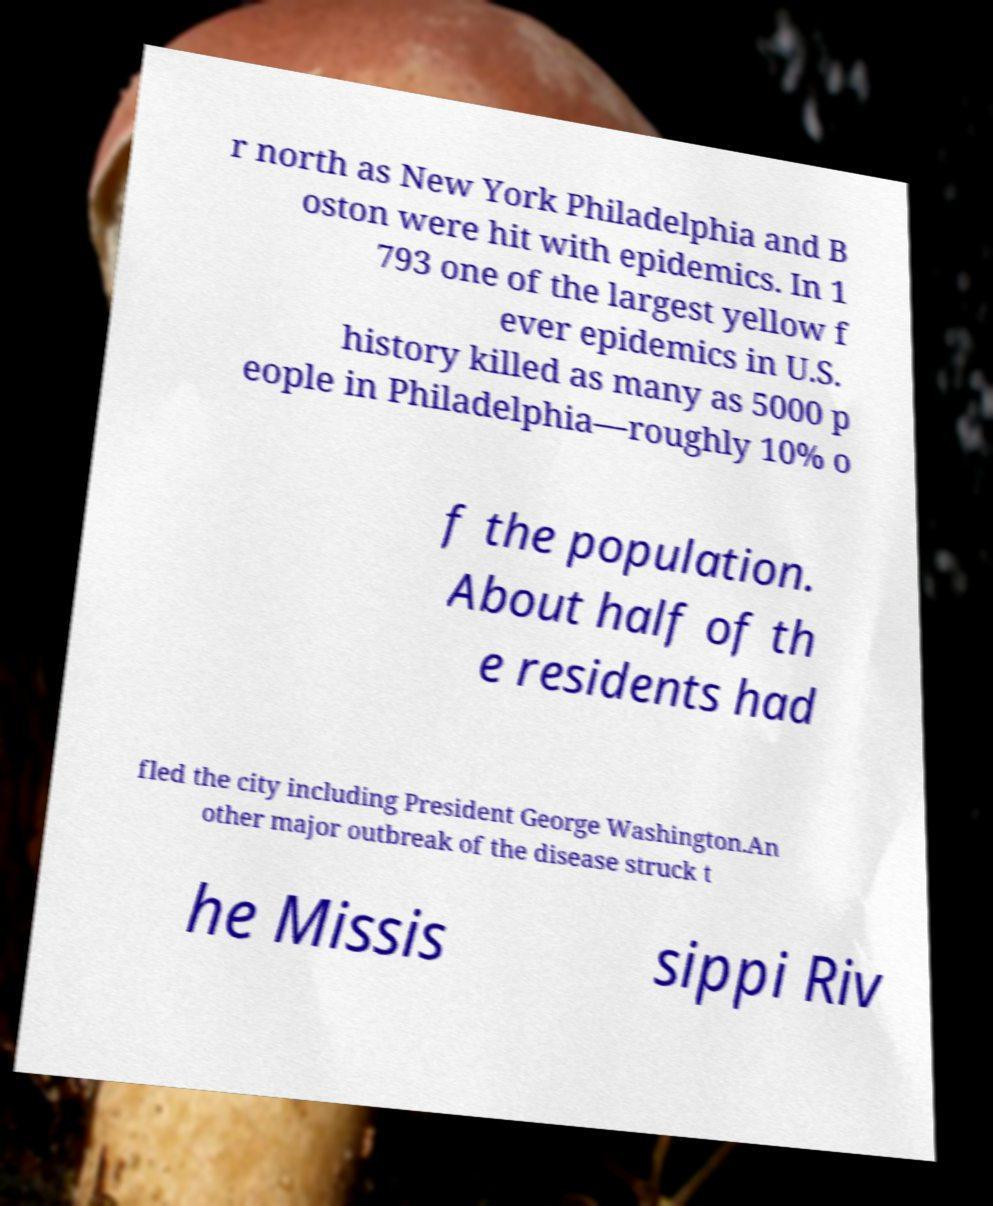For documentation purposes, I need the text within this image transcribed. Could you provide that? r north as New York Philadelphia and B oston were hit with epidemics. In 1 793 one of the largest yellow f ever epidemics in U.S. history killed as many as 5000 p eople in Philadelphia—roughly 10% o f the population. About half of th e residents had fled the city including President George Washington.An other major outbreak of the disease struck t he Missis sippi Riv 